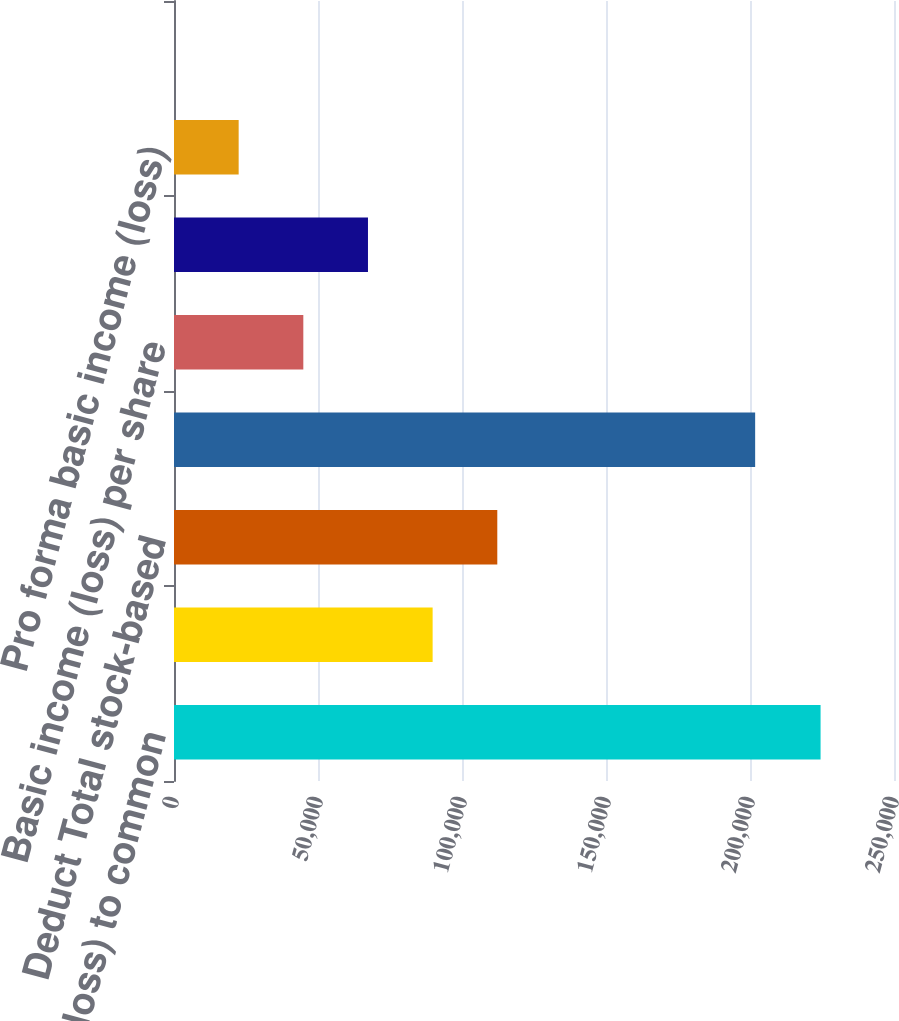Convert chart to OTSL. <chart><loc_0><loc_0><loc_500><loc_500><bar_chart><fcel>Net income (loss) to common<fcel>Add Stock-based employee<fcel>Deduct Total stock-based<fcel>Pro forma net income (loss) to<fcel>Basic income (loss) per share<fcel>Diluted income (loss) per<fcel>Pro forma basic income (loss)<fcel>Pro forma diluted income<nl><fcel>224506<fcel>89802.6<fcel>112253<fcel>201788<fcel>44901.5<fcel>67352.1<fcel>22451<fcel>0.41<nl></chart> 